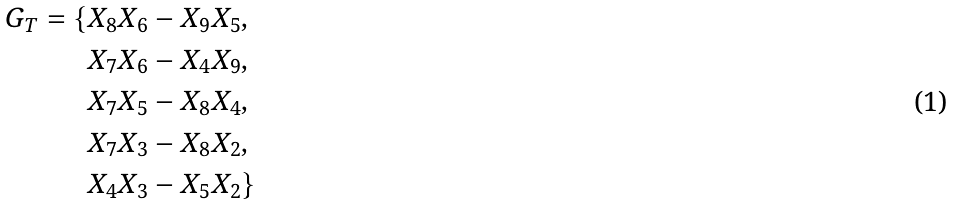<formula> <loc_0><loc_0><loc_500><loc_500>G _ { T } = \{ X _ { 8 } X _ { 6 } & - X _ { 9 } X _ { 5 } , \\ X _ { 7 } X _ { 6 } & - X _ { 4 } X _ { 9 } , \\ X _ { 7 } X _ { 5 } & - X _ { 8 } X _ { 4 } , \\ X _ { 7 } X _ { 3 } & - X _ { 8 } X _ { 2 } , \\ X _ { 4 } X _ { 3 } & - X _ { 5 } X _ { 2 } \}</formula> 